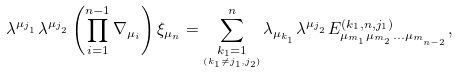Convert formula to latex. <formula><loc_0><loc_0><loc_500><loc_500>\lambda ^ { \mu _ { j _ { _ { 1 } } } } \lambda ^ { \mu _ { j _ { _ { 2 } } } } \left ( \prod _ { i = 1 } ^ { n - 1 } \nabla _ { \mu _ { i } } \right ) \xi _ { \mu _ { n } } = \sum _ { \underset { \left ( k _ { 1 } \ne j _ { 1 } , j _ { 2 } \right ) } { k _ { 1 } = 1 } } ^ { n } \lambda _ { \mu _ { k _ { _ { 1 } } } } \lambda ^ { \mu _ { j _ { _ { 2 } } } } E _ { \mu _ { m _ { _ { 1 } } } \mu _ { m _ { _ { 2 } } } \dots \mu _ { m _ { _ { n - 2 } } } } ^ { \left ( k _ { 1 } , n , j _ { 1 } \right ) } ,</formula> 